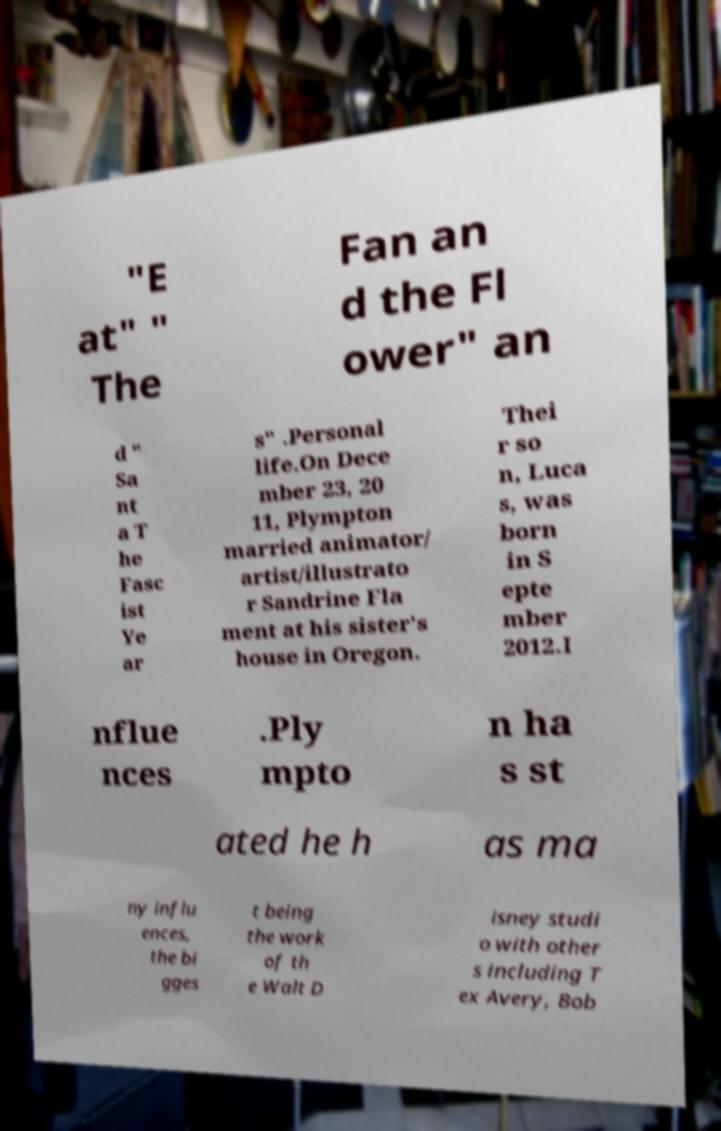Can you accurately transcribe the text from the provided image for me? "E at" " The Fan an d the Fl ower" an d " Sa nt a T he Fasc ist Ye ar s" .Personal life.On Dece mber 23, 20 11, Plympton married animator/ artist/illustrato r Sandrine Fla ment at his sister's house in Oregon. Thei r so n, Luca s, was born in S epte mber 2012.I nflue nces .Ply mpto n ha s st ated he h as ma ny influ ences, the bi gges t being the work of th e Walt D isney studi o with other s including T ex Avery, Bob 